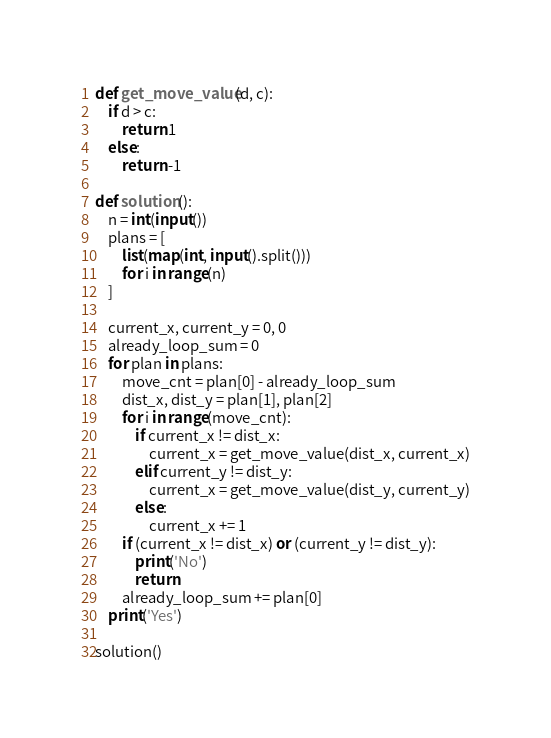<code> <loc_0><loc_0><loc_500><loc_500><_Python_>def get_move_value(d, c):
    if d > c:
        return 1
    else:
        return -1

def solution():
    n = int(input())
    plans = [
        list(map(int, input().split()))
        for i in range(n)
    ]

    current_x, current_y = 0, 0
    already_loop_sum = 0
    for plan in plans:
        move_cnt = plan[0] - already_loop_sum
        dist_x, dist_y = plan[1], plan[2]
        for i in range(move_cnt):
            if current_x != dist_x:
                current_x = get_move_value(dist_x, current_x)
            elif current_y != dist_y:
                current_x = get_move_value(dist_y, current_y)
            else:
                current_x += 1
        if (current_x != dist_x) or (current_y != dist_y):
            print('No')
            return
        already_loop_sum += plan[0]
    print('Yes')

solution()</code> 